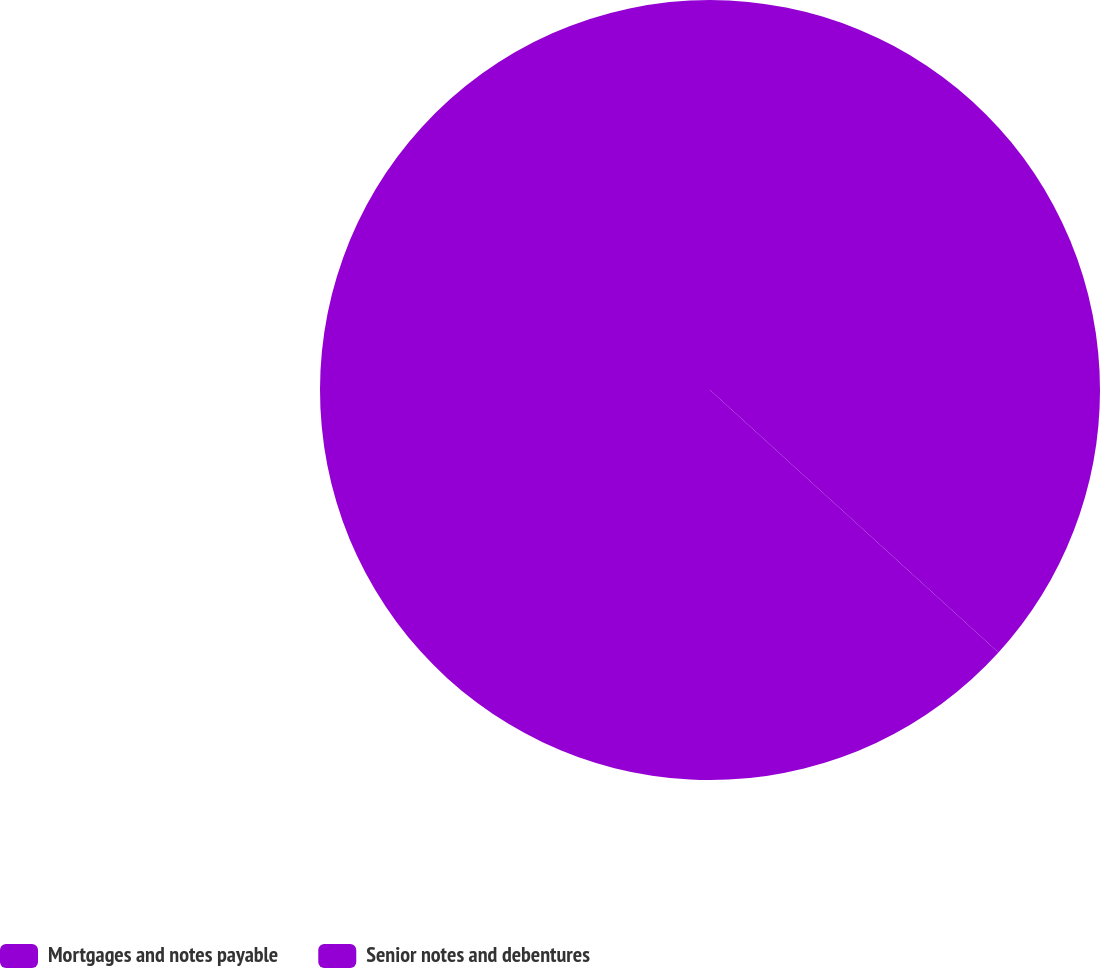Convert chart to OTSL. <chart><loc_0><loc_0><loc_500><loc_500><pie_chart><fcel>Mortgages and notes payable<fcel>Senior notes and debentures<nl><fcel>36.75%<fcel>63.25%<nl></chart> 